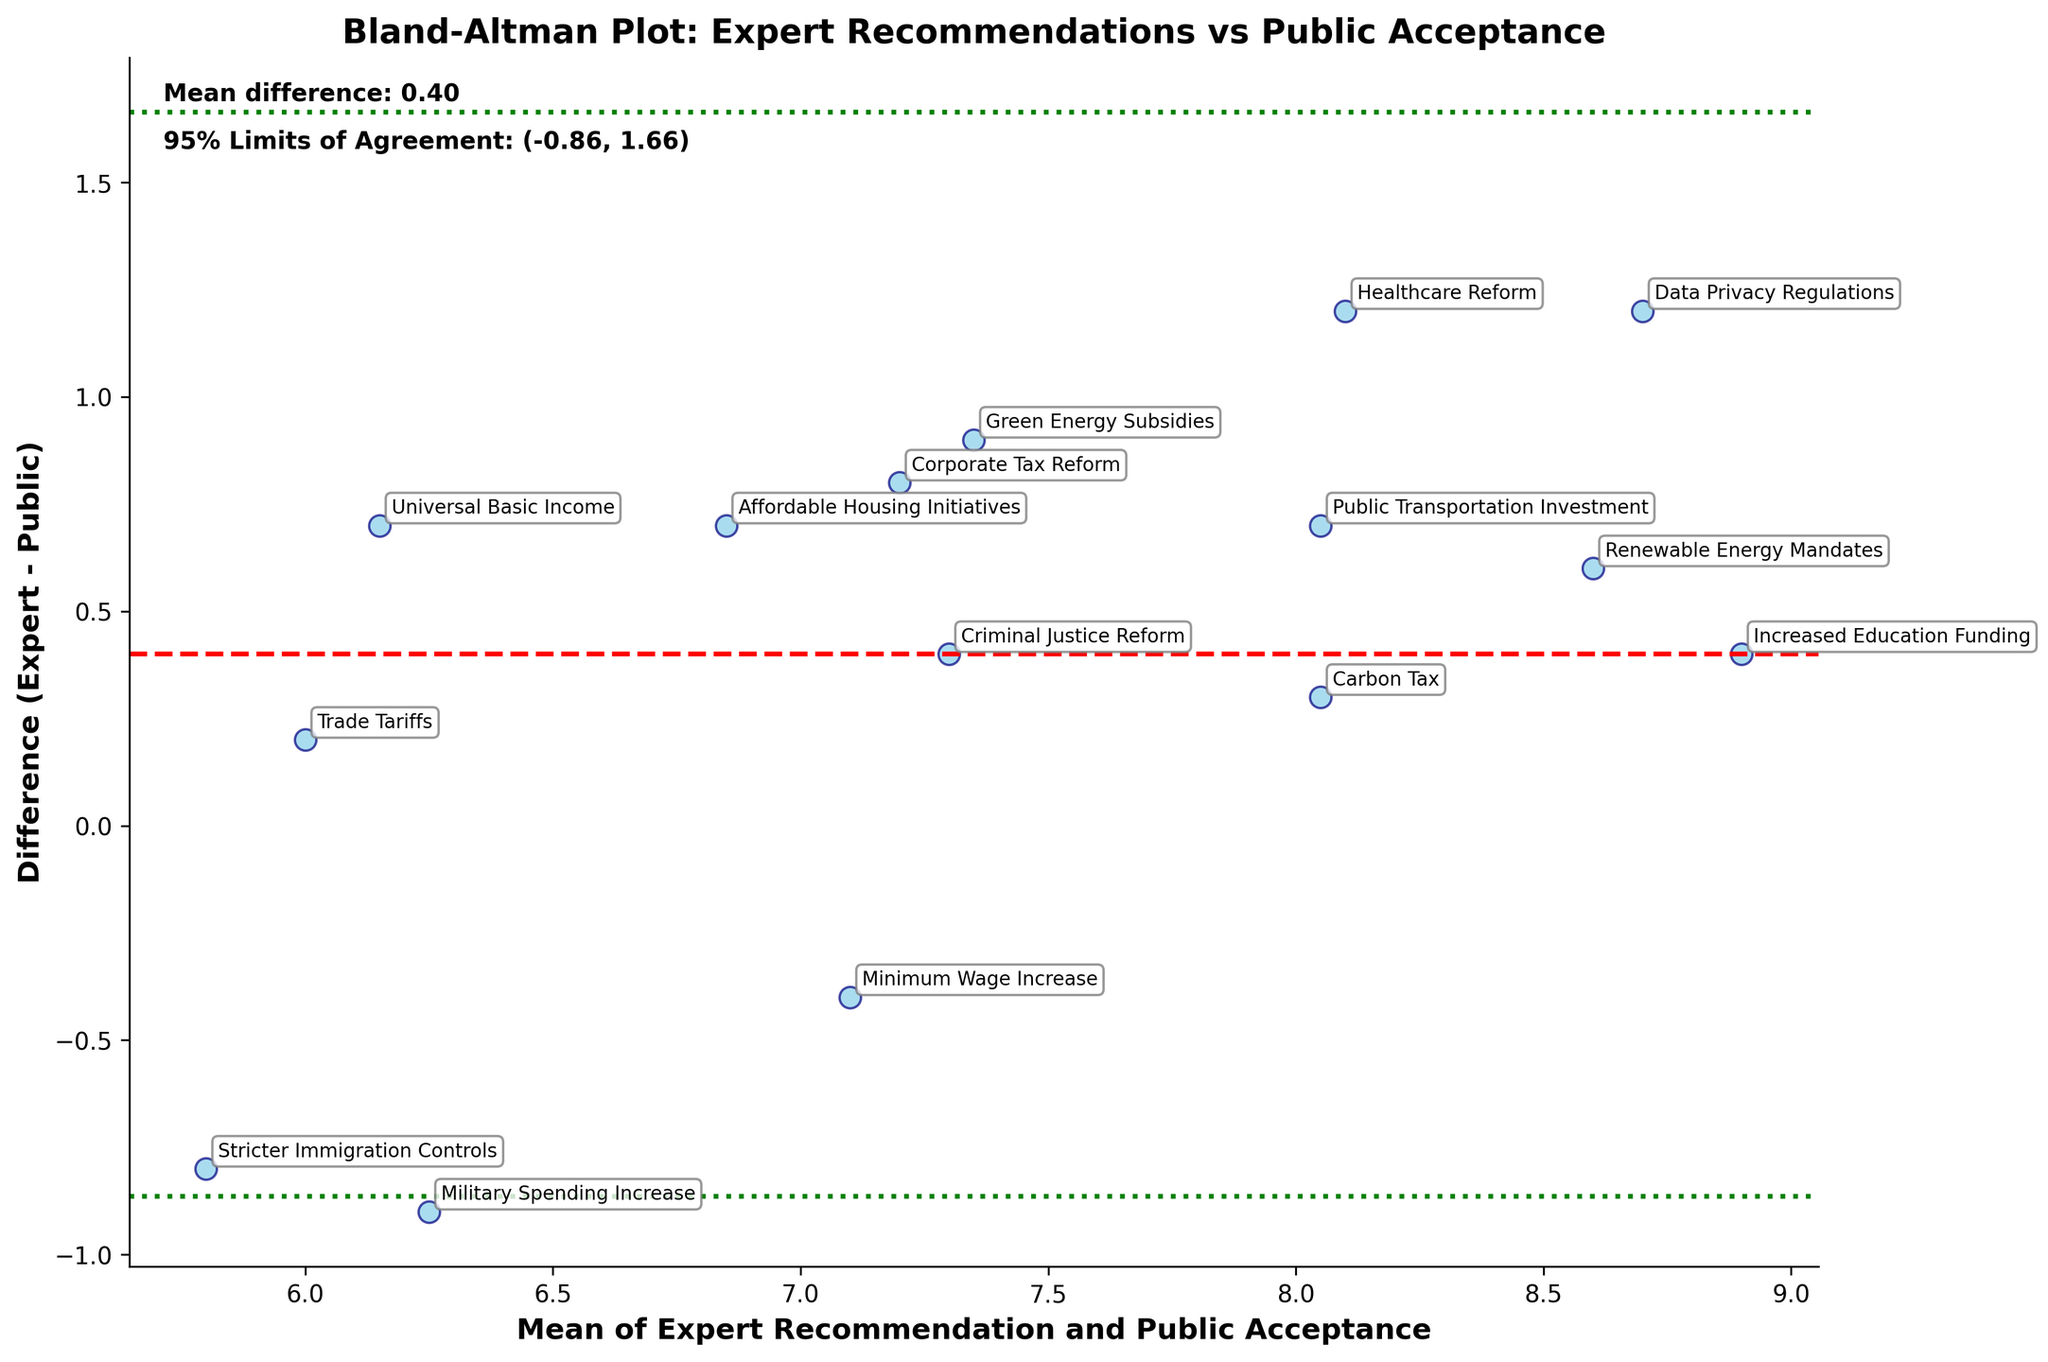what is the title of the plot? The title is located at the top of the figure and usually describes the content of the plot. Here, it reads 'Bland–Altman Plot: Expert Recommendations vs Public Acceptance'.
Answer: Bland-Altman Plot: Expert Recommendations vs Public Acceptance How many data points are plotted? Each scatter point represents a pair of values from the expert recommendations and public acceptance. Counting the markers on the plot gives the number of data points, which corresponds to the rows in our dataset.
Answer: 15 What is the mean difference between Expert Recommendations and Public Acceptance? The mean difference is depicted as a horizontal red dashed line on the plot. It is also mentioned in the text at the top left of the figure as 'Mean difference: ...'.
Answer: Mean difference: 0.60 What are the 95% limits of agreement? The 95% limits of agreement are shown as two green dotted horizontal lines on the figure. Additionally, these values are mentioned in the text at the top left of the figure.
Answer: (-0.45, 1.65) Which policy area has the highest mean value between expert recommendations and public acceptance? To find this, look at the point furthest to the right on the X-axis (Mean of Expert Recommendation and Public Acceptance), and check the annotated policy label.
Answer: Data Privacy Regulations Which policy area shows the largest difference (expert-public)? The vertical axis represents the difference between expert recommendations and public acceptance. The point farthest from the x-axis (either up or down) indicates the largest difference.
Answer: Healthcare Reform Is there any policy where public acceptance is higher than expert recommendation? Identify points below the x-axis (Difference (Expert - Public) < 0) as these indicate cases where public acceptance exceeds expert recommendations.
Answer: Stricter Immigration Controls and Military Spending Increase Explain the significance of the red dashed line and the green dotted lines. The red dashed line represents the mean difference between expert recommendations and public acceptance, indicating the average bias. The green dotted lines establish the 95% limits of agreement, within which most (about 95%) of the differences between expert recommendations and public acceptance lie, giving a range for agreement limits.
Answer: Mean bias and agreement limits Do any policy areas show a near-perfect concordance between expert recommendations and public acceptance? To determine this, find the points closest to the horizontal x-axis (Difference ≈ 0), as these represent minimal discrepancy between the expert recommendations and public acceptance.
Answer: Trade Tariffs, Universal Basic Income What can be inferred if a data point falls outside the 95% limits of agreement? Points outside the green dotted lines are considered outliers, suggesting a significant discrepancy between expert recommendations and public acceptance for those policy areas, indicating less concordance.
Answer: Significant discrepancy 